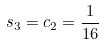<formula> <loc_0><loc_0><loc_500><loc_500>s _ { 3 } = c _ { 2 } = \frac { 1 } { 1 6 }</formula> 